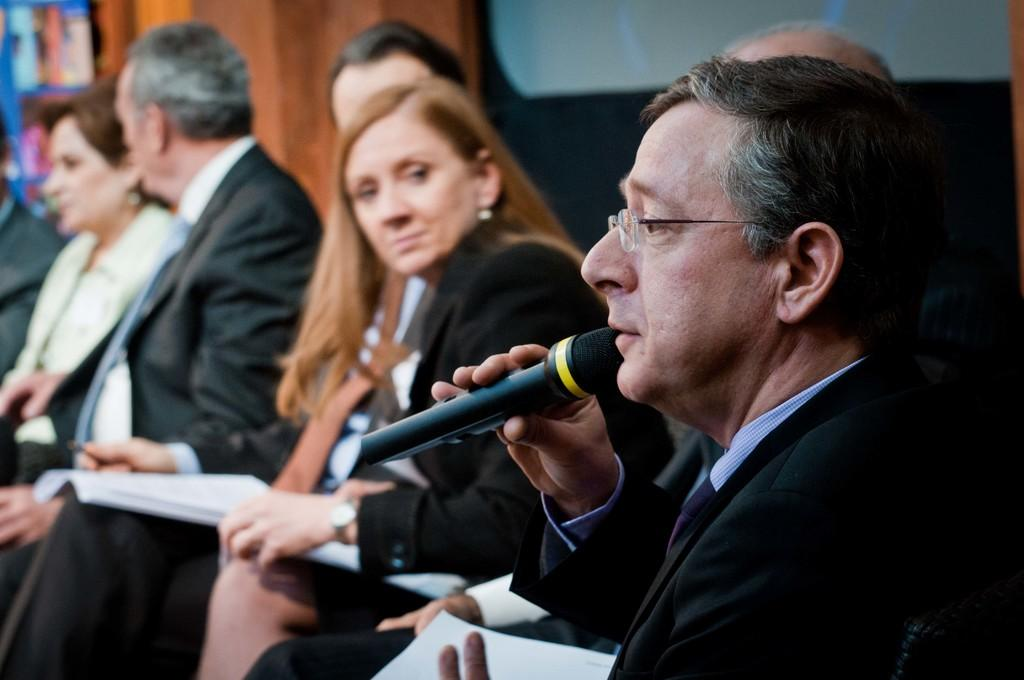What is the main subject of the image? The main subject of the image is a group of people. What are the people in the image doing? The people are sitting on chairs. Can you describe the appearance of one of the individuals in the group? There is a man in a black blazer with spectacles. What is the man holding in the image? The man is holding a microphone. What can be seen in the background of the image? There is a wall in the background of the image. What type of sweater is the man wearing in the image? The man is not wearing a sweater in the image; he is wearing a black blazer. How does the man in the black blazer get the attention of the group? The image does not show the man attempting to get the attention of the group, so it cannot be determined from the image. 